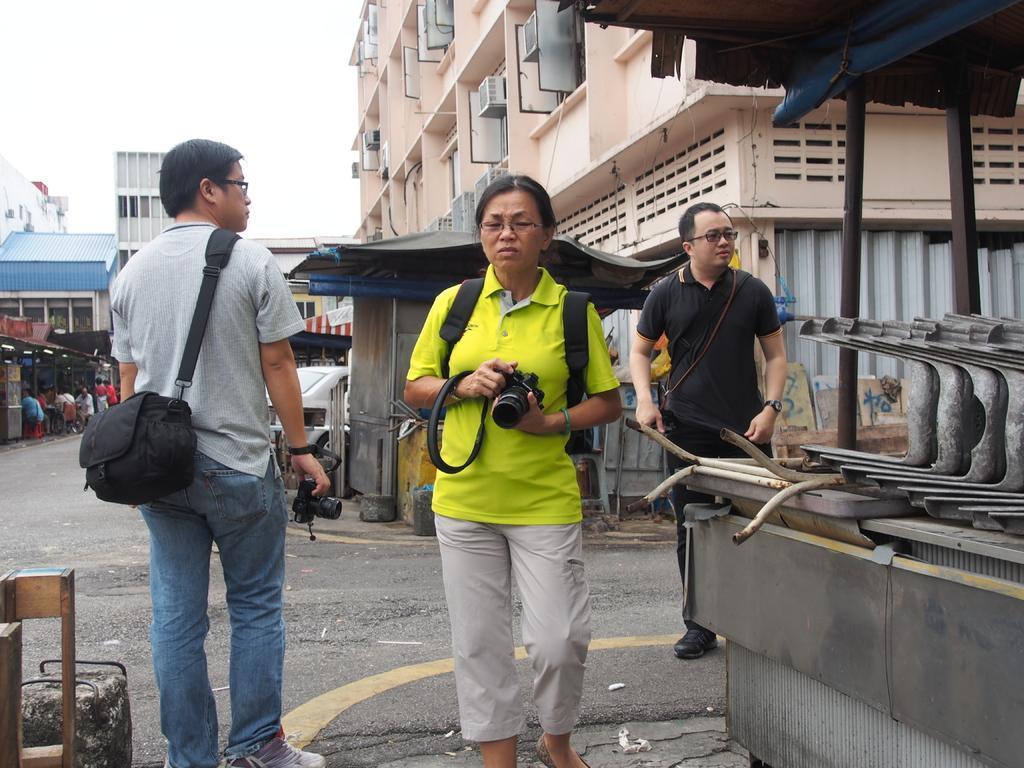How would you summarize this image in a sentence or two? in this image on the right side one person is standing and on the left side another person is standing and he is holding the bag and in the middle the woman is standing and on the left side there are some people sitting on the chair behind the three persons there is a building and the background is very cloudy. 